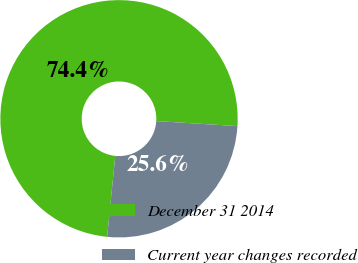<chart> <loc_0><loc_0><loc_500><loc_500><pie_chart><fcel>December 31 2014<fcel>Current year changes recorded<nl><fcel>74.39%<fcel>25.61%<nl></chart> 